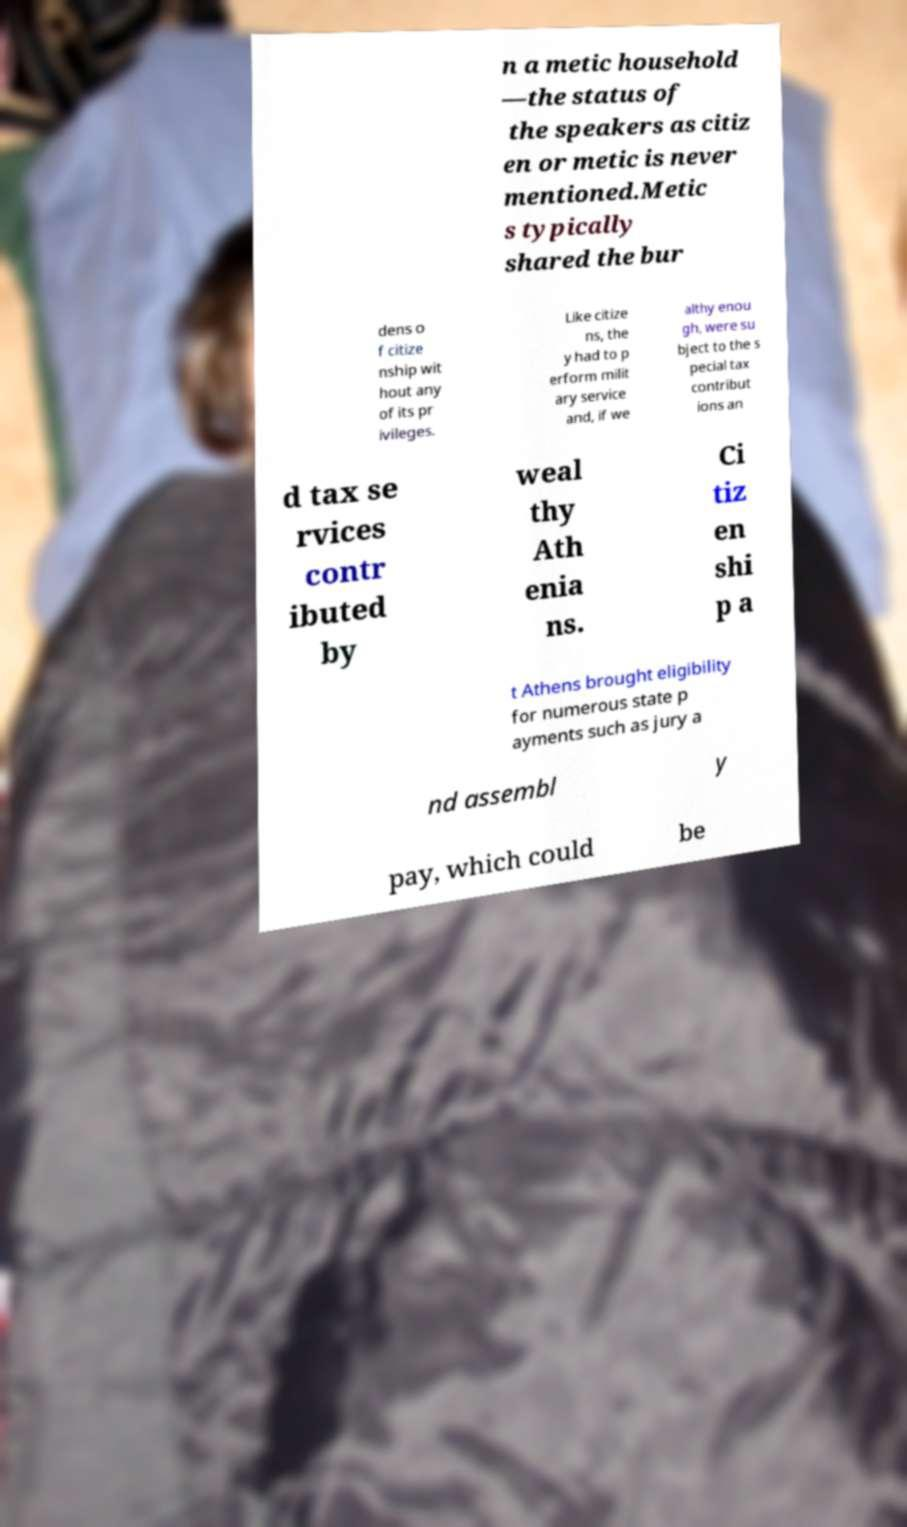Please identify and transcribe the text found in this image. n a metic household —the status of the speakers as citiz en or metic is never mentioned.Metic s typically shared the bur dens o f citize nship wit hout any of its pr ivileges. Like citize ns, the y had to p erform milit ary service and, if we althy enou gh, were su bject to the s pecial tax contribut ions an d tax se rvices contr ibuted by weal thy Ath enia ns. Ci tiz en shi p a t Athens brought eligibility for numerous state p ayments such as jury a nd assembl y pay, which could be 